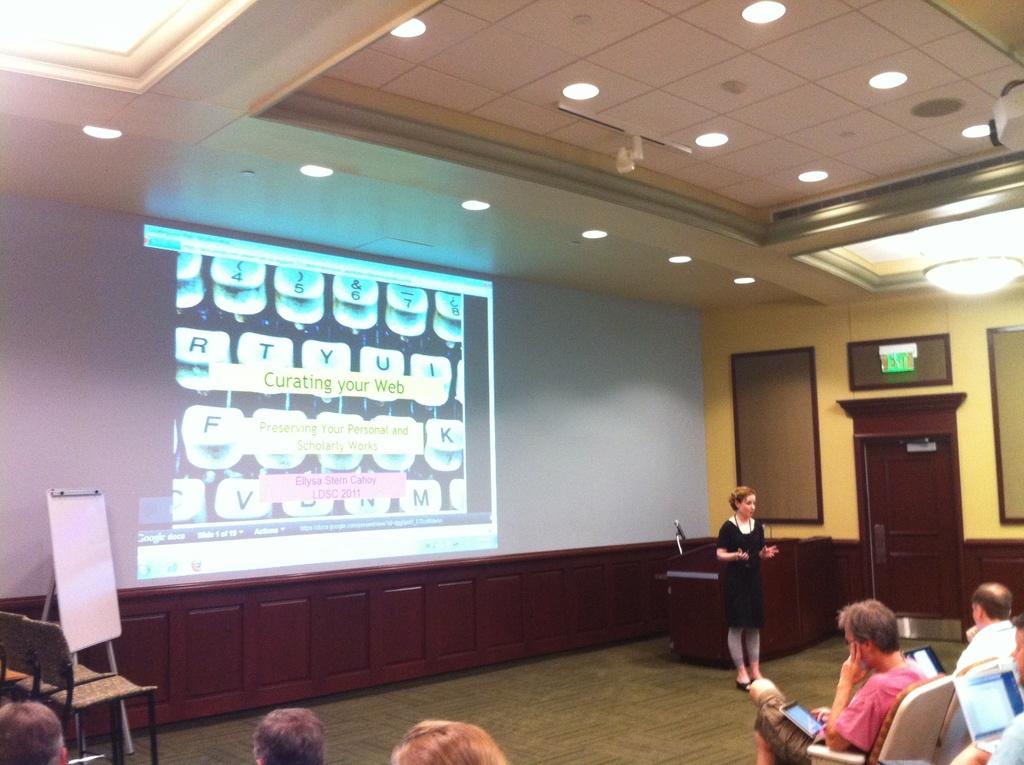What is the title of this powerpoint?
Your answer should be compact. Curating your web. What is the first letter of the title of the power point?
Make the answer very short. C. 